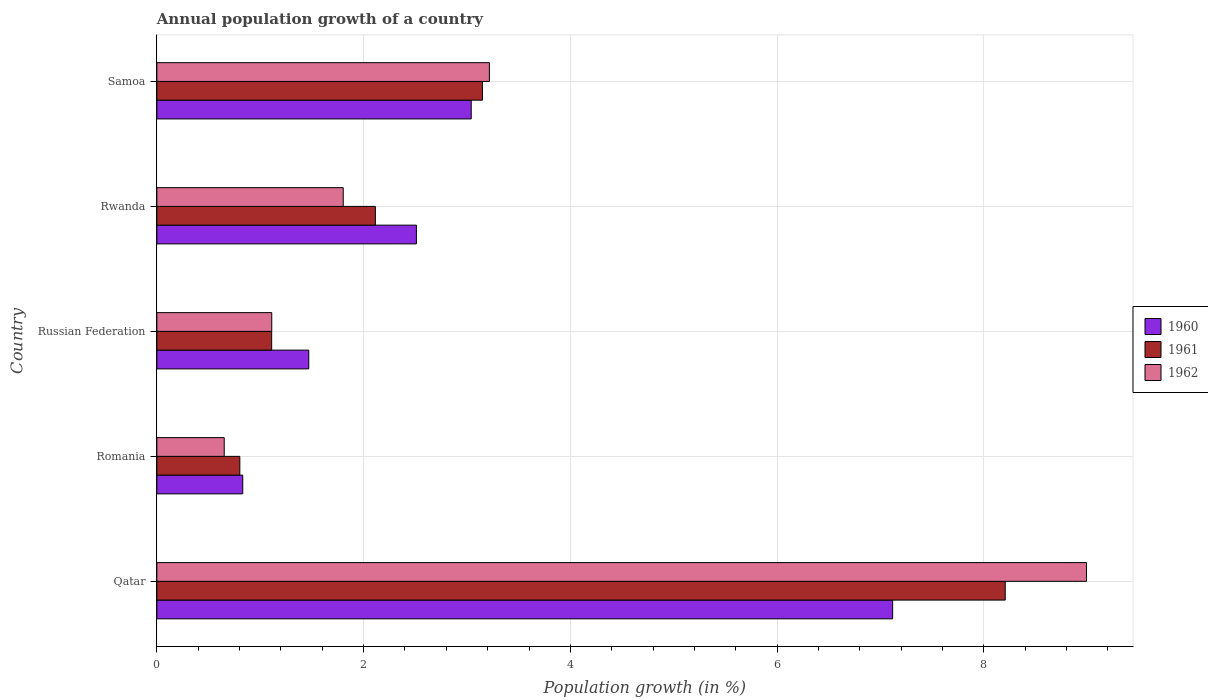How many different coloured bars are there?
Make the answer very short. 3. Are the number of bars on each tick of the Y-axis equal?
Your answer should be compact. Yes. How many bars are there on the 3rd tick from the top?
Provide a succinct answer. 3. How many bars are there on the 2nd tick from the bottom?
Ensure brevity in your answer.  3. What is the label of the 1st group of bars from the top?
Keep it short and to the point. Samoa. In how many cases, is the number of bars for a given country not equal to the number of legend labels?
Ensure brevity in your answer.  0. What is the annual population growth in 1962 in Russian Federation?
Offer a terse response. 1.11. Across all countries, what is the maximum annual population growth in 1960?
Your answer should be compact. 7.12. Across all countries, what is the minimum annual population growth in 1961?
Your response must be concise. 0.8. In which country was the annual population growth in 1961 maximum?
Offer a terse response. Qatar. In which country was the annual population growth in 1961 minimum?
Your response must be concise. Romania. What is the total annual population growth in 1961 in the graph?
Ensure brevity in your answer.  15.38. What is the difference between the annual population growth in 1961 in Romania and that in Rwanda?
Ensure brevity in your answer.  -1.31. What is the difference between the annual population growth in 1960 in Romania and the annual population growth in 1961 in Rwanda?
Offer a terse response. -1.28. What is the average annual population growth in 1961 per country?
Provide a succinct answer. 3.08. What is the difference between the annual population growth in 1960 and annual population growth in 1961 in Samoa?
Offer a terse response. -0.11. In how many countries, is the annual population growth in 1962 greater than 5.2 %?
Ensure brevity in your answer.  1. What is the ratio of the annual population growth in 1962 in Russian Federation to that in Rwanda?
Provide a short and direct response. 0.62. What is the difference between the highest and the second highest annual population growth in 1960?
Offer a terse response. 4.08. What is the difference between the highest and the lowest annual population growth in 1962?
Ensure brevity in your answer.  8.34. Is it the case that in every country, the sum of the annual population growth in 1960 and annual population growth in 1961 is greater than the annual population growth in 1962?
Your answer should be compact. Yes. How many bars are there?
Provide a short and direct response. 15. How many countries are there in the graph?
Your answer should be compact. 5. What is the difference between two consecutive major ticks on the X-axis?
Your answer should be compact. 2. Does the graph contain any zero values?
Keep it short and to the point. No. Where does the legend appear in the graph?
Your answer should be compact. Center right. What is the title of the graph?
Give a very brief answer. Annual population growth of a country. What is the label or title of the X-axis?
Ensure brevity in your answer.  Population growth (in %). What is the Population growth (in %) of 1960 in Qatar?
Your response must be concise. 7.12. What is the Population growth (in %) in 1961 in Qatar?
Provide a short and direct response. 8.21. What is the Population growth (in %) in 1962 in Qatar?
Provide a short and direct response. 8.99. What is the Population growth (in %) of 1960 in Romania?
Offer a terse response. 0.83. What is the Population growth (in %) of 1961 in Romania?
Make the answer very short. 0.8. What is the Population growth (in %) in 1962 in Romania?
Offer a very short reply. 0.65. What is the Population growth (in %) of 1960 in Russian Federation?
Provide a succinct answer. 1.47. What is the Population growth (in %) of 1961 in Russian Federation?
Keep it short and to the point. 1.11. What is the Population growth (in %) in 1962 in Russian Federation?
Give a very brief answer. 1.11. What is the Population growth (in %) of 1960 in Rwanda?
Ensure brevity in your answer.  2.51. What is the Population growth (in %) of 1961 in Rwanda?
Your answer should be compact. 2.11. What is the Population growth (in %) in 1962 in Rwanda?
Your response must be concise. 1.8. What is the Population growth (in %) of 1960 in Samoa?
Give a very brief answer. 3.04. What is the Population growth (in %) in 1961 in Samoa?
Ensure brevity in your answer.  3.15. What is the Population growth (in %) of 1962 in Samoa?
Your answer should be compact. 3.22. Across all countries, what is the maximum Population growth (in %) of 1960?
Your answer should be compact. 7.12. Across all countries, what is the maximum Population growth (in %) of 1961?
Offer a terse response. 8.21. Across all countries, what is the maximum Population growth (in %) in 1962?
Offer a very short reply. 8.99. Across all countries, what is the minimum Population growth (in %) of 1960?
Give a very brief answer. 0.83. Across all countries, what is the minimum Population growth (in %) in 1961?
Offer a terse response. 0.8. Across all countries, what is the minimum Population growth (in %) of 1962?
Ensure brevity in your answer.  0.65. What is the total Population growth (in %) in 1960 in the graph?
Offer a very short reply. 14.97. What is the total Population growth (in %) in 1961 in the graph?
Offer a terse response. 15.38. What is the total Population growth (in %) of 1962 in the graph?
Your response must be concise. 15.77. What is the difference between the Population growth (in %) of 1960 in Qatar and that in Romania?
Provide a short and direct response. 6.29. What is the difference between the Population growth (in %) of 1961 in Qatar and that in Romania?
Your answer should be compact. 7.4. What is the difference between the Population growth (in %) in 1962 in Qatar and that in Romania?
Offer a very short reply. 8.34. What is the difference between the Population growth (in %) in 1960 in Qatar and that in Russian Federation?
Offer a terse response. 5.65. What is the difference between the Population growth (in %) in 1961 in Qatar and that in Russian Federation?
Your response must be concise. 7.1. What is the difference between the Population growth (in %) of 1962 in Qatar and that in Russian Federation?
Give a very brief answer. 7.88. What is the difference between the Population growth (in %) of 1960 in Qatar and that in Rwanda?
Give a very brief answer. 4.61. What is the difference between the Population growth (in %) in 1961 in Qatar and that in Rwanda?
Offer a very short reply. 6.09. What is the difference between the Population growth (in %) of 1962 in Qatar and that in Rwanda?
Keep it short and to the point. 7.19. What is the difference between the Population growth (in %) in 1960 in Qatar and that in Samoa?
Make the answer very short. 4.08. What is the difference between the Population growth (in %) of 1961 in Qatar and that in Samoa?
Make the answer very short. 5.06. What is the difference between the Population growth (in %) in 1962 in Qatar and that in Samoa?
Provide a succinct answer. 5.78. What is the difference between the Population growth (in %) of 1960 in Romania and that in Russian Federation?
Your answer should be very brief. -0.64. What is the difference between the Population growth (in %) of 1961 in Romania and that in Russian Federation?
Ensure brevity in your answer.  -0.31. What is the difference between the Population growth (in %) in 1962 in Romania and that in Russian Federation?
Make the answer very short. -0.46. What is the difference between the Population growth (in %) in 1960 in Romania and that in Rwanda?
Offer a terse response. -1.68. What is the difference between the Population growth (in %) in 1961 in Romania and that in Rwanda?
Make the answer very short. -1.31. What is the difference between the Population growth (in %) in 1962 in Romania and that in Rwanda?
Keep it short and to the point. -1.15. What is the difference between the Population growth (in %) in 1960 in Romania and that in Samoa?
Ensure brevity in your answer.  -2.21. What is the difference between the Population growth (in %) in 1961 in Romania and that in Samoa?
Give a very brief answer. -2.35. What is the difference between the Population growth (in %) of 1962 in Romania and that in Samoa?
Ensure brevity in your answer.  -2.56. What is the difference between the Population growth (in %) in 1960 in Russian Federation and that in Rwanda?
Offer a terse response. -1.04. What is the difference between the Population growth (in %) of 1961 in Russian Federation and that in Rwanda?
Your answer should be very brief. -1. What is the difference between the Population growth (in %) of 1962 in Russian Federation and that in Rwanda?
Give a very brief answer. -0.69. What is the difference between the Population growth (in %) of 1960 in Russian Federation and that in Samoa?
Make the answer very short. -1.57. What is the difference between the Population growth (in %) in 1961 in Russian Federation and that in Samoa?
Ensure brevity in your answer.  -2.04. What is the difference between the Population growth (in %) of 1962 in Russian Federation and that in Samoa?
Provide a short and direct response. -2.1. What is the difference between the Population growth (in %) of 1960 in Rwanda and that in Samoa?
Provide a succinct answer. -0.53. What is the difference between the Population growth (in %) of 1961 in Rwanda and that in Samoa?
Provide a succinct answer. -1.04. What is the difference between the Population growth (in %) in 1962 in Rwanda and that in Samoa?
Provide a short and direct response. -1.41. What is the difference between the Population growth (in %) in 1960 in Qatar and the Population growth (in %) in 1961 in Romania?
Provide a short and direct response. 6.31. What is the difference between the Population growth (in %) in 1960 in Qatar and the Population growth (in %) in 1962 in Romania?
Your answer should be compact. 6.47. What is the difference between the Population growth (in %) in 1961 in Qatar and the Population growth (in %) in 1962 in Romania?
Provide a succinct answer. 7.55. What is the difference between the Population growth (in %) in 1960 in Qatar and the Population growth (in %) in 1961 in Russian Federation?
Ensure brevity in your answer.  6.01. What is the difference between the Population growth (in %) of 1960 in Qatar and the Population growth (in %) of 1962 in Russian Federation?
Your response must be concise. 6.01. What is the difference between the Population growth (in %) in 1961 in Qatar and the Population growth (in %) in 1962 in Russian Federation?
Offer a terse response. 7.09. What is the difference between the Population growth (in %) of 1960 in Qatar and the Population growth (in %) of 1961 in Rwanda?
Keep it short and to the point. 5. What is the difference between the Population growth (in %) of 1960 in Qatar and the Population growth (in %) of 1962 in Rwanda?
Give a very brief answer. 5.31. What is the difference between the Population growth (in %) of 1961 in Qatar and the Population growth (in %) of 1962 in Rwanda?
Keep it short and to the point. 6.4. What is the difference between the Population growth (in %) in 1960 in Qatar and the Population growth (in %) in 1961 in Samoa?
Your answer should be compact. 3.97. What is the difference between the Population growth (in %) of 1960 in Qatar and the Population growth (in %) of 1962 in Samoa?
Keep it short and to the point. 3.9. What is the difference between the Population growth (in %) in 1961 in Qatar and the Population growth (in %) in 1962 in Samoa?
Give a very brief answer. 4.99. What is the difference between the Population growth (in %) of 1960 in Romania and the Population growth (in %) of 1961 in Russian Federation?
Your answer should be very brief. -0.28. What is the difference between the Population growth (in %) of 1960 in Romania and the Population growth (in %) of 1962 in Russian Federation?
Make the answer very short. -0.28. What is the difference between the Population growth (in %) of 1961 in Romania and the Population growth (in %) of 1962 in Russian Federation?
Your answer should be very brief. -0.31. What is the difference between the Population growth (in %) in 1960 in Romania and the Population growth (in %) in 1961 in Rwanda?
Provide a short and direct response. -1.28. What is the difference between the Population growth (in %) in 1960 in Romania and the Population growth (in %) in 1962 in Rwanda?
Give a very brief answer. -0.97. What is the difference between the Population growth (in %) of 1961 in Romania and the Population growth (in %) of 1962 in Rwanda?
Ensure brevity in your answer.  -1. What is the difference between the Population growth (in %) in 1960 in Romania and the Population growth (in %) in 1961 in Samoa?
Provide a succinct answer. -2.32. What is the difference between the Population growth (in %) in 1960 in Romania and the Population growth (in %) in 1962 in Samoa?
Keep it short and to the point. -2.39. What is the difference between the Population growth (in %) of 1961 in Romania and the Population growth (in %) of 1962 in Samoa?
Provide a short and direct response. -2.41. What is the difference between the Population growth (in %) of 1960 in Russian Federation and the Population growth (in %) of 1961 in Rwanda?
Your response must be concise. -0.64. What is the difference between the Population growth (in %) of 1960 in Russian Federation and the Population growth (in %) of 1962 in Rwanda?
Ensure brevity in your answer.  -0.33. What is the difference between the Population growth (in %) in 1961 in Russian Federation and the Population growth (in %) in 1962 in Rwanda?
Make the answer very short. -0.69. What is the difference between the Population growth (in %) of 1960 in Russian Federation and the Population growth (in %) of 1961 in Samoa?
Your answer should be very brief. -1.68. What is the difference between the Population growth (in %) in 1960 in Russian Federation and the Population growth (in %) in 1962 in Samoa?
Provide a succinct answer. -1.75. What is the difference between the Population growth (in %) of 1961 in Russian Federation and the Population growth (in %) of 1962 in Samoa?
Offer a very short reply. -2.11. What is the difference between the Population growth (in %) of 1960 in Rwanda and the Population growth (in %) of 1961 in Samoa?
Offer a terse response. -0.64. What is the difference between the Population growth (in %) of 1960 in Rwanda and the Population growth (in %) of 1962 in Samoa?
Offer a terse response. -0.71. What is the difference between the Population growth (in %) in 1961 in Rwanda and the Population growth (in %) in 1962 in Samoa?
Your answer should be compact. -1.1. What is the average Population growth (in %) in 1960 per country?
Provide a short and direct response. 2.99. What is the average Population growth (in %) in 1961 per country?
Your answer should be compact. 3.08. What is the average Population growth (in %) of 1962 per country?
Keep it short and to the point. 3.15. What is the difference between the Population growth (in %) of 1960 and Population growth (in %) of 1961 in Qatar?
Offer a terse response. -1.09. What is the difference between the Population growth (in %) in 1960 and Population growth (in %) in 1962 in Qatar?
Offer a terse response. -1.88. What is the difference between the Population growth (in %) of 1961 and Population growth (in %) of 1962 in Qatar?
Your answer should be compact. -0.79. What is the difference between the Population growth (in %) in 1960 and Population growth (in %) in 1961 in Romania?
Keep it short and to the point. 0.03. What is the difference between the Population growth (in %) in 1960 and Population growth (in %) in 1962 in Romania?
Provide a succinct answer. 0.18. What is the difference between the Population growth (in %) in 1961 and Population growth (in %) in 1962 in Romania?
Give a very brief answer. 0.15. What is the difference between the Population growth (in %) in 1960 and Population growth (in %) in 1961 in Russian Federation?
Offer a terse response. 0.36. What is the difference between the Population growth (in %) of 1960 and Population growth (in %) of 1962 in Russian Federation?
Your answer should be very brief. 0.36. What is the difference between the Population growth (in %) in 1961 and Population growth (in %) in 1962 in Russian Federation?
Offer a terse response. -0. What is the difference between the Population growth (in %) in 1960 and Population growth (in %) in 1961 in Rwanda?
Your response must be concise. 0.4. What is the difference between the Population growth (in %) of 1960 and Population growth (in %) of 1962 in Rwanda?
Provide a short and direct response. 0.71. What is the difference between the Population growth (in %) of 1961 and Population growth (in %) of 1962 in Rwanda?
Offer a terse response. 0.31. What is the difference between the Population growth (in %) of 1960 and Population growth (in %) of 1961 in Samoa?
Provide a succinct answer. -0.11. What is the difference between the Population growth (in %) in 1960 and Population growth (in %) in 1962 in Samoa?
Keep it short and to the point. -0.18. What is the difference between the Population growth (in %) in 1961 and Population growth (in %) in 1962 in Samoa?
Offer a very short reply. -0.07. What is the ratio of the Population growth (in %) of 1960 in Qatar to that in Romania?
Offer a terse response. 8.57. What is the ratio of the Population growth (in %) of 1961 in Qatar to that in Romania?
Your answer should be very brief. 10.22. What is the ratio of the Population growth (in %) of 1962 in Qatar to that in Romania?
Offer a terse response. 13.8. What is the ratio of the Population growth (in %) of 1960 in Qatar to that in Russian Federation?
Your response must be concise. 4.84. What is the ratio of the Population growth (in %) in 1961 in Qatar to that in Russian Federation?
Your response must be concise. 7.39. What is the ratio of the Population growth (in %) in 1962 in Qatar to that in Russian Federation?
Your answer should be very brief. 8.09. What is the ratio of the Population growth (in %) in 1960 in Qatar to that in Rwanda?
Make the answer very short. 2.83. What is the ratio of the Population growth (in %) of 1961 in Qatar to that in Rwanda?
Your response must be concise. 3.88. What is the ratio of the Population growth (in %) of 1962 in Qatar to that in Rwanda?
Provide a short and direct response. 4.99. What is the ratio of the Population growth (in %) of 1960 in Qatar to that in Samoa?
Make the answer very short. 2.34. What is the ratio of the Population growth (in %) of 1961 in Qatar to that in Samoa?
Your answer should be very brief. 2.61. What is the ratio of the Population growth (in %) in 1962 in Qatar to that in Samoa?
Provide a short and direct response. 2.8. What is the ratio of the Population growth (in %) in 1960 in Romania to that in Russian Federation?
Provide a succinct answer. 0.57. What is the ratio of the Population growth (in %) in 1961 in Romania to that in Russian Federation?
Offer a terse response. 0.72. What is the ratio of the Population growth (in %) in 1962 in Romania to that in Russian Federation?
Keep it short and to the point. 0.59. What is the ratio of the Population growth (in %) of 1960 in Romania to that in Rwanda?
Offer a terse response. 0.33. What is the ratio of the Population growth (in %) in 1961 in Romania to that in Rwanda?
Give a very brief answer. 0.38. What is the ratio of the Population growth (in %) in 1962 in Romania to that in Rwanda?
Offer a very short reply. 0.36. What is the ratio of the Population growth (in %) in 1960 in Romania to that in Samoa?
Keep it short and to the point. 0.27. What is the ratio of the Population growth (in %) in 1961 in Romania to that in Samoa?
Keep it short and to the point. 0.25. What is the ratio of the Population growth (in %) in 1962 in Romania to that in Samoa?
Give a very brief answer. 0.2. What is the ratio of the Population growth (in %) of 1960 in Russian Federation to that in Rwanda?
Provide a succinct answer. 0.59. What is the ratio of the Population growth (in %) of 1961 in Russian Federation to that in Rwanda?
Ensure brevity in your answer.  0.53. What is the ratio of the Population growth (in %) of 1962 in Russian Federation to that in Rwanda?
Make the answer very short. 0.62. What is the ratio of the Population growth (in %) of 1960 in Russian Federation to that in Samoa?
Offer a very short reply. 0.48. What is the ratio of the Population growth (in %) of 1961 in Russian Federation to that in Samoa?
Ensure brevity in your answer.  0.35. What is the ratio of the Population growth (in %) in 1962 in Russian Federation to that in Samoa?
Provide a short and direct response. 0.35. What is the ratio of the Population growth (in %) in 1960 in Rwanda to that in Samoa?
Provide a succinct answer. 0.83. What is the ratio of the Population growth (in %) of 1961 in Rwanda to that in Samoa?
Offer a terse response. 0.67. What is the ratio of the Population growth (in %) in 1962 in Rwanda to that in Samoa?
Your answer should be very brief. 0.56. What is the difference between the highest and the second highest Population growth (in %) of 1960?
Your response must be concise. 4.08. What is the difference between the highest and the second highest Population growth (in %) of 1961?
Provide a short and direct response. 5.06. What is the difference between the highest and the second highest Population growth (in %) in 1962?
Your answer should be compact. 5.78. What is the difference between the highest and the lowest Population growth (in %) of 1960?
Offer a terse response. 6.29. What is the difference between the highest and the lowest Population growth (in %) of 1961?
Provide a succinct answer. 7.4. What is the difference between the highest and the lowest Population growth (in %) of 1962?
Your answer should be very brief. 8.34. 